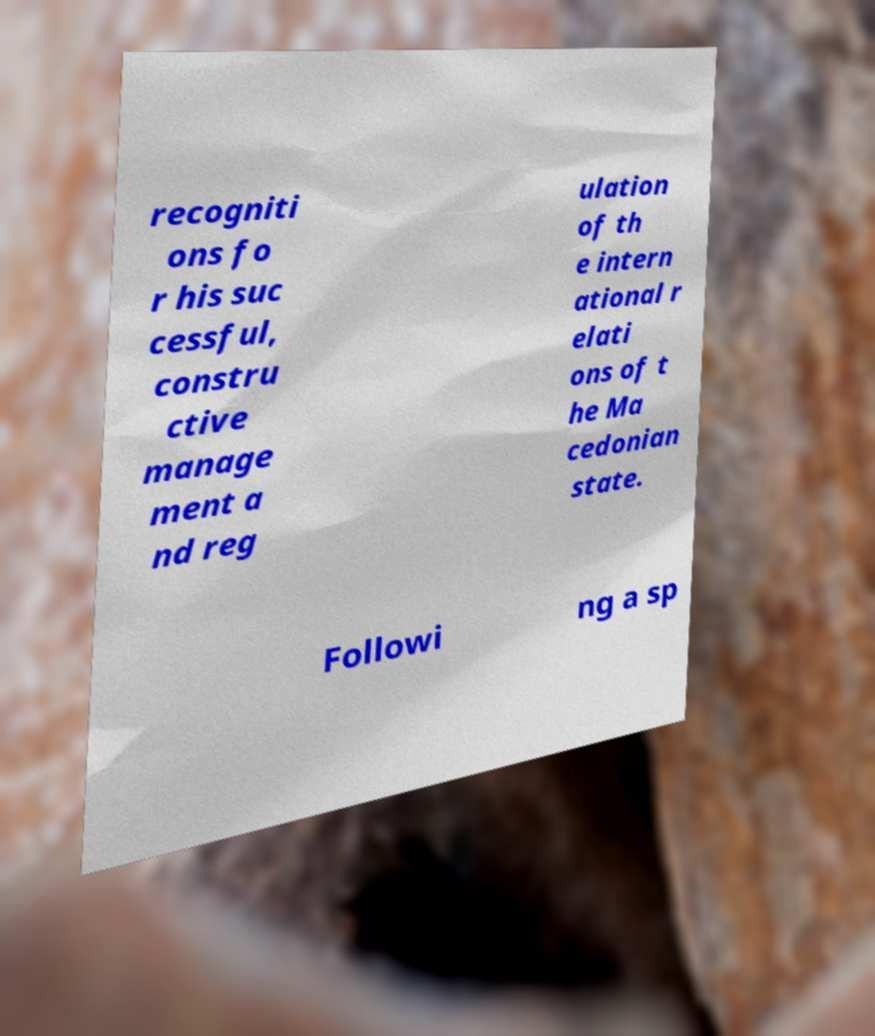Can you accurately transcribe the text from the provided image for me? recogniti ons fo r his suc cessful, constru ctive manage ment a nd reg ulation of th e intern ational r elati ons of t he Ma cedonian state. Followi ng a sp 